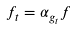Convert formula to latex. <formula><loc_0><loc_0><loc_500><loc_500>f _ { t } = \alpha _ { g _ { t } } f</formula> 